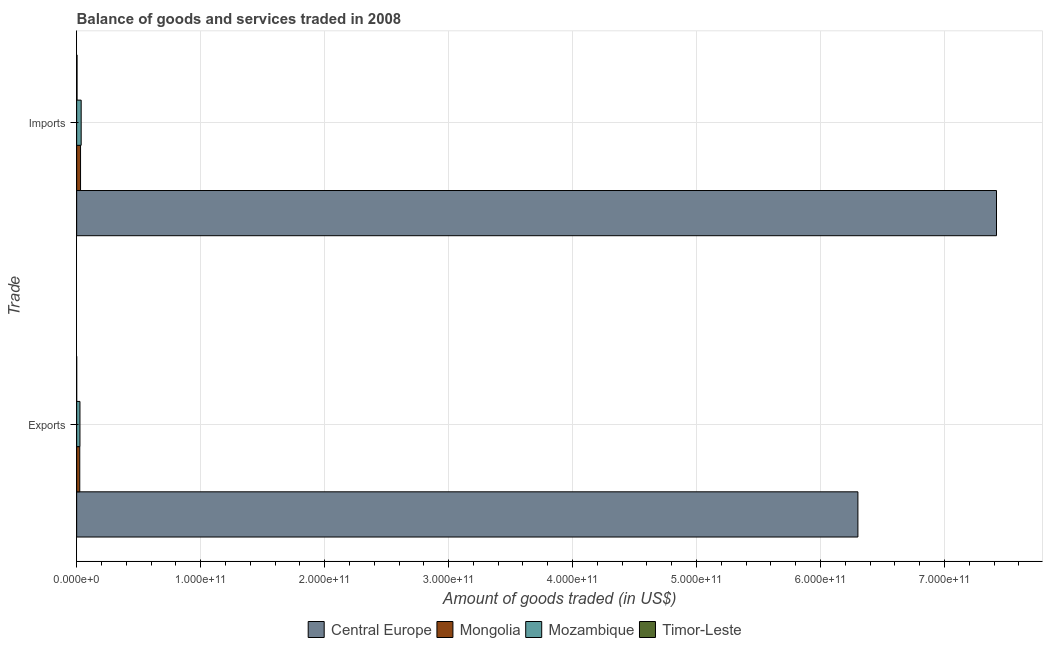How many groups of bars are there?
Make the answer very short. 2. Are the number of bars per tick equal to the number of legend labels?
Offer a terse response. Yes. Are the number of bars on each tick of the Y-axis equal?
Your response must be concise. Yes. How many bars are there on the 2nd tick from the top?
Offer a very short reply. 4. What is the label of the 2nd group of bars from the top?
Your answer should be very brief. Exports. What is the amount of goods imported in Mongolia?
Make the answer very short. 3.14e+09. Across all countries, what is the maximum amount of goods exported?
Ensure brevity in your answer.  6.30e+11. Across all countries, what is the minimum amount of goods imported?
Give a very brief answer. 3.11e+08. In which country was the amount of goods imported maximum?
Keep it short and to the point. Central Europe. In which country was the amount of goods exported minimum?
Provide a succinct answer. Timor-Leste. What is the total amount of goods exported in the graph?
Make the answer very short. 6.35e+11. What is the difference between the amount of goods exported in Mongolia and that in Central Europe?
Give a very brief answer. -6.28e+11. What is the difference between the amount of goods exported in Mongolia and the amount of goods imported in Timor-Leste?
Your answer should be compact. 2.20e+09. What is the average amount of goods imported per country?
Provide a short and direct response. 1.87e+11. What is the difference between the amount of goods imported and amount of goods exported in Mozambique?
Ensure brevity in your answer.  9.90e+08. In how many countries, is the amount of goods exported greater than 660000000000 US$?
Offer a terse response. 0. What is the ratio of the amount of goods exported in Timor-Leste to that in Central Europe?
Your answer should be very brief. 2.23138105247732e-5. What does the 3rd bar from the top in Imports represents?
Offer a very short reply. Mongolia. What does the 3rd bar from the bottom in Exports represents?
Your answer should be very brief. Mozambique. Are all the bars in the graph horizontal?
Provide a succinct answer. Yes. How many countries are there in the graph?
Your response must be concise. 4. What is the difference between two consecutive major ticks on the X-axis?
Make the answer very short. 1.00e+11. Does the graph contain any zero values?
Offer a terse response. No. Does the graph contain grids?
Ensure brevity in your answer.  Yes. Where does the legend appear in the graph?
Your answer should be very brief. Bottom center. How are the legend labels stacked?
Offer a very short reply. Horizontal. What is the title of the graph?
Offer a terse response. Balance of goods and services traded in 2008. Does "Euro area" appear as one of the legend labels in the graph?
Your response must be concise. No. What is the label or title of the X-axis?
Your response must be concise. Amount of goods traded (in US$). What is the label or title of the Y-axis?
Offer a terse response. Trade. What is the Amount of goods traded (in US$) in Central Europe in Exports?
Offer a terse response. 6.30e+11. What is the Amount of goods traded (in US$) of Mongolia in Exports?
Give a very brief answer. 2.51e+09. What is the Amount of goods traded (in US$) in Mozambique in Exports?
Your answer should be very brief. 2.65e+09. What is the Amount of goods traded (in US$) in Timor-Leste in Exports?
Offer a very short reply. 1.41e+07. What is the Amount of goods traded (in US$) in Central Europe in Imports?
Offer a very short reply. 7.42e+11. What is the Amount of goods traded (in US$) of Mongolia in Imports?
Your answer should be very brief. 3.14e+09. What is the Amount of goods traded (in US$) of Mozambique in Imports?
Make the answer very short. 3.64e+09. What is the Amount of goods traded (in US$) of Timor-Leste in Imports?
Give a very brief answer. 3.11e+08. Across all Trade, what is the maximum Amount of goods traded (in US$) of Central Europe?
Keep it short and to the point. 7.42e+11. Across all Trade, what is the maximum Amount of goods traded (in US$) of Mongolia?
Provide a succinct answer. 3.14e+09. Across all Trade, what is the maximum Amount of goods traded (in US$) of Mozambique?
Give a very brief answer. 3.64e+09. Across all Trade, what is the maximum Amount of goods traded (in US$) in Timor-Leste?
Keep it short and to the point. 3.11e+08. Across all Trade, what is the minimum Amount of goods traded (in US$) in Central Europe?
Keep it short and to the point. 6.30e+11. Across all Trade, what is the minimum Amount of goods traded (in US$) of Mongolia?
Offer a very short reply. 2.51e+09. Across all Trade, what is the minimum Amount of goods traded (in US$) in Mozambique?
Provide a succinct answer. 2.65e+09. Across all Trade, what is the minimum Amount of goods traded (in US$) in Timor-Leste?
Offer a terse response. 1.41e+07. What is the total Amount of goods traded (in US$) in Central Europe in the graph?
Give a very brief answer. 1.37e+12. What is the total Amount of goods traded (in US$) in Mongolia in the graph?
Give a very brief answer. 5.65e+09. What is the total Amount of goods traded (in US$) of Mozambique in the graph?
Provide a succinct answer. 6.30e+09. What is the total Amount of goods traded (in US$) in Timor-Leste in the graph?
Offer a very short reply. 3.25e+08. What is the difference between the Amount of goods traded (in US$) of Central Europe in Exports and that in Imports?
Provide a succinct answer. -1.12e+11. What is the difference between the Amount of goods traded (in US$) in Mongolia in Exports and that in Imports?
Your answer should be compact. -6.29e+08. What is the difference between the Amount of goods traded (in US$) in Mozambique in Exports and that in Imports?
Offer a very short reply. -9.90e+08. What is the difference between the Amount of goods traded (in US$) in Timor-Leste in Exports and that in Imports?
Your answer should be compact. -2.97e+08. What is the difference between the Amount of goods traded (in US$) of Central Europe in Exports and the Amount of goods traded (in US$) of Mongolia in Imports?
Give a very brief answer. 6.27e+11. What is the difference between the Amount of goods traded (in US$) of Central Europe in Exports and the Amount of goods traded (in US$) of Mozambique in Imports?
Give a very brief answer. 6.27e+11. What is the difference between the Amount of goods traded (in US$) in Central Europe in Exports and the Amount of goods traded (in US$) in Timor-Leste in Imports?
Offer a very short reply. 6.30e+11. What is the difference between the Amount of goods traded (in US$) of Mongolia in Exports and the Amount of goods traded (in US$) of Mozambique in Imports?
Offer a very short reply. -1.13e+09. What is the difference between the Amount of goods traded (in US$) in Mongolia in Exports and the Amount of goods traded (in US$) in Timor-Leste in Imports?
Your response must be concise. 2.20e+09. What is the difference between the Amount of goods traded (in US$) in Mozambique in Exports and the Amount of goods traded (in US$) in Timor-Leste in Imports?
Offer a very short reply. 2.34e+09. What is the average Amount of goods traded (in US$) in Central Europe per Trade?
Offer a very short reply. 6.86e+11. What is the average Amount of goods traded (in US$) in Mongolia per Trade?
Your response must be concise. 2.82e+09. What is the average Amount of goods traded (in US$) of Mozambique per Trade?
Offer a terse response. 3.15e+09. What is the average Amount of goods traded (in US$) of Timor-Leste per Trade?
Offer a very short reply. 1.62e+08. What is the difference between the Amount of goods traded (in US$) in Central Europe and Amount of goods traded (in US$) in Mongolia in Exports?
Keep it short and to the point. 6.28e+11. What is the difference between the Amount of goods traded (in US$) of Central Europe and Amount of goods traded (in US$) of Mozambique in Exports?
Provide a succinct answer. 6.28e+11. What is the difference between the Amount of goods traded (in US$) in Central Europe and Amount of goods traded (in US$) in Timor-Leste in Exports?
Provide a succinct answer. 6.30e+11. What is the difference between the Amount of goods traded (in US$) of Mongolia and Amount of goods traded (in US$) of Mozambique in Exports?
Provide a succinct answer. -1.45e+08. What is the difference between the Amount of goods traded (in US$) of Mongolia and Amount of goods traded (in US$) of Timor-Leste in Exports?
Make the answer very short. 2.49e+09. What is the difference between the Amount of goods traded (in US$) of Mozambique and Amount of goods traded (in US$) of Timor-Leste in Exports?
Provide a short and direct response. 2.64e+09. What is the difference between the Amount of goods traded (in US$) of Central Europe and Amount of goods traded (in US$) of Mongolia in Imports?
Make the answer very short. 7.39e+11. What is the difference between the Amount of goods traded (in US$) in Central Europe and Amount of goods traded (in US$) in Mozambique in Imports?
Provide a succinct answer. 7.38e+11. What is the difference between the Amount of goods traded (in US$) in Central Europe and Amount of goods traded (in US$) in Timor-Leste in Imports?
Ensure brevity in your answer.  7.42e+11. What is the difference between the Amount of goods traded (in US$) of Mongolia and Amount of goods traded (in US$) of Mozambique in Imports?
Ensure brevity in your answer.  -5.05e+08. What is the difference between the Amount of goods traded (in US$) of Mongolia and Amount of goods traded (in US$) of Timor-Leste in Imports?
Your response must be concise. 2.83e+09. What is the difference between the Amount of goods traded (in US$) of Mozambique and Amount of goods traded (in US$) of Timor-Leste in Imports?
Your response must be concise. 3.33e+09. What is the ratio of the Amount of goods traded (in US$) in Central Europe in Exports to that in Imports?
Give a very brief answer. 0.85. What is the ratio of the Amount of goods traded (in US$) in Mongolia in Exports to that in Imports?
Provide a succinct answer. 0.8. What is the ratio of the Amount of goods traded (in US$) in Mozambique in Exports to that in Imports?
Ensure brevity in your answer.  0.73. What is the ratio of the Amount of goods traded (in US$) in Timor-Leste in Exports to that in Imports?
Keep it short and to the point. 0.05. What is the difference between the highest and the second highest Amount of goods traded (in US$) of Central Europe?
Make the answer very short. 1.12e+11. What is the difference between the highest and the second highest Amount of goods traded (in US$) of Mongolia?
Keep it short and to the point. 6.29e+08. What is the difference between the highest and the second highest Amount of goods traded (in US$) of Mozambique?
Give a very brief answer. 9.90e+08. What is the difference between the highest and the second highest Amount of goods traded (in US$) in Timor-Leste?
Keep it short and to the point. 2.97e+08. What is the difference between the highest and the lowest Amount of goods traded (in US$) in Central Europe?
Make the answer very short. 1.12e+11. What is the difference between the highest and the lowest Amount of goods traded (in US$) of Mongolia?
Your answer should be very brief. 6.29e+08. What is the difference between the highest and the lowest Amount of goods traded (in US$) in Mozambique?
Your response must be concise. 9.90e+08. What is the difference between the highest and the lowest Amount of goods traded (in US$) of Timor-Leste?
Provide a short and direct response. 2.97e+08. 